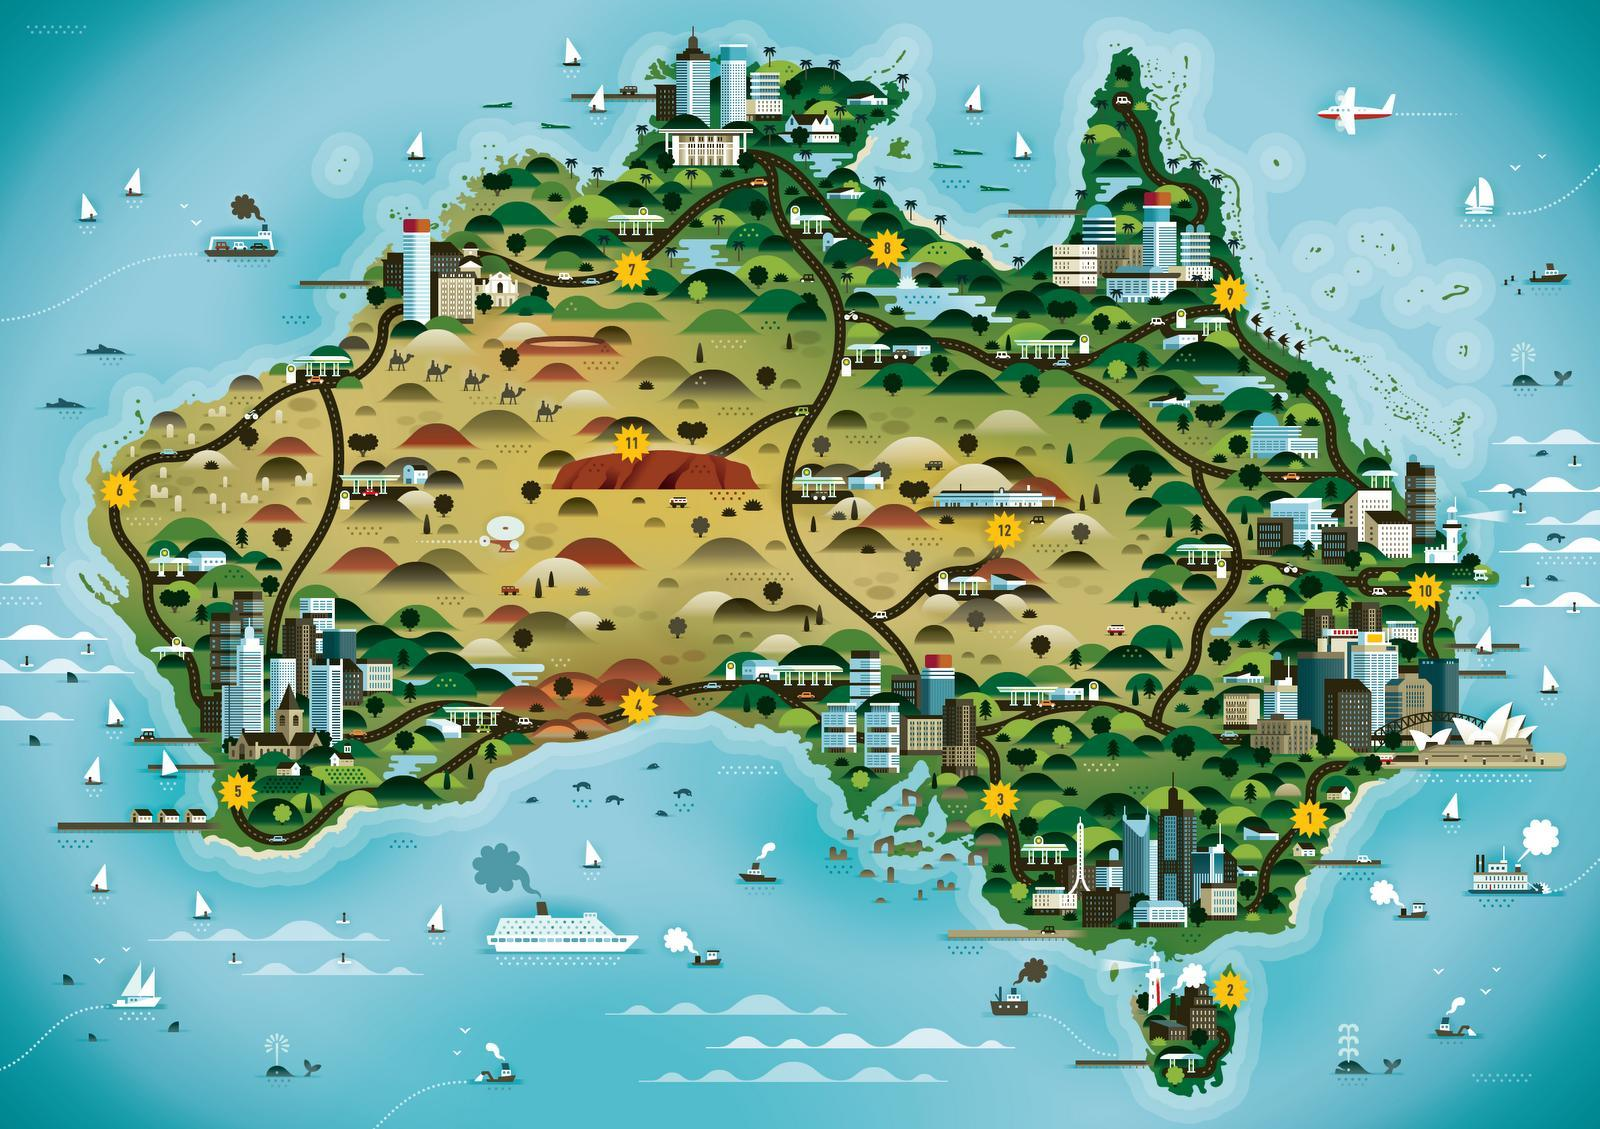How many regions are shown in the map?
Answer the question with a short phrase. 12 How many camels are shown in the info graphic? 5 